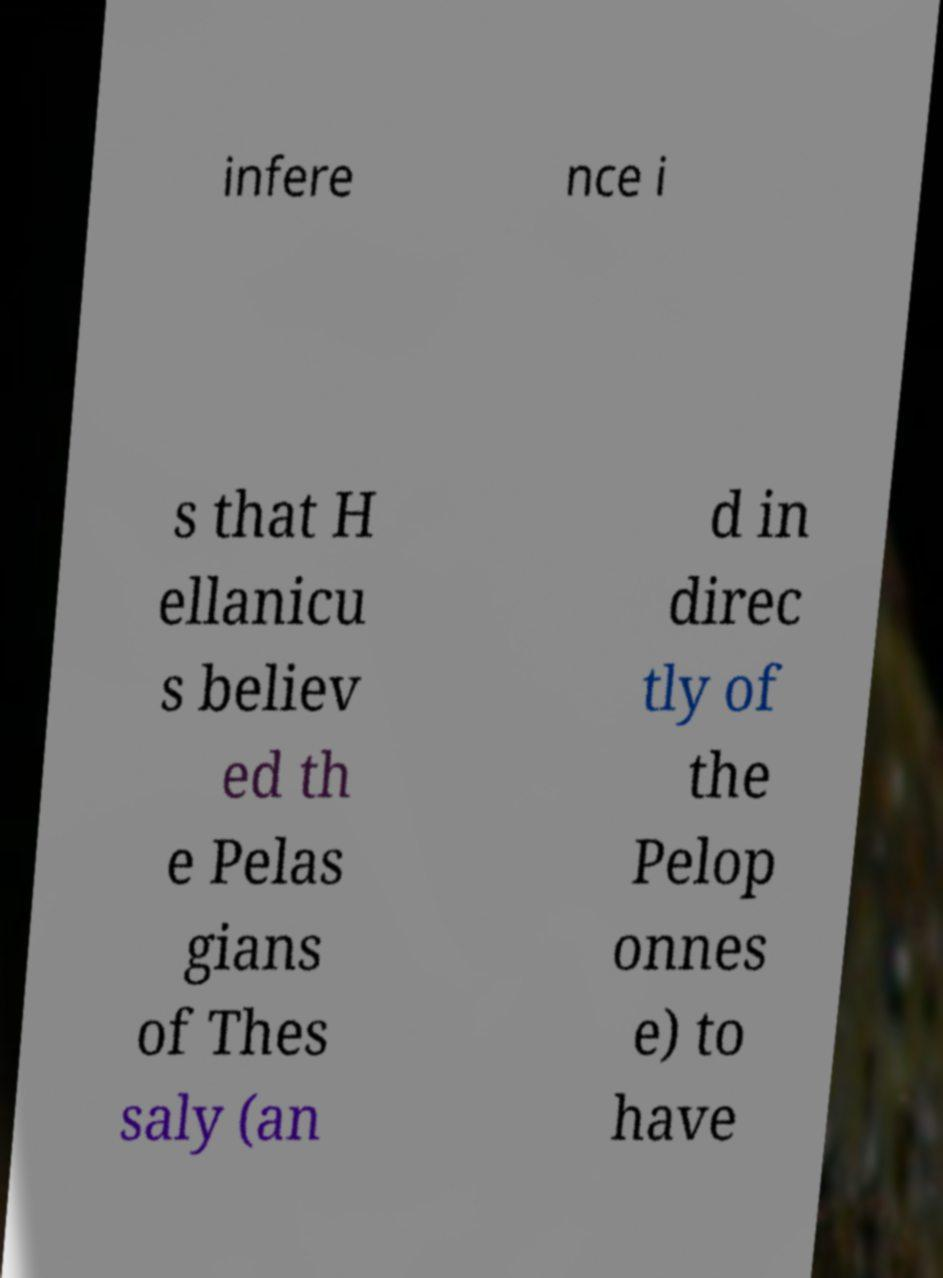Could you extract and type out the text from this image? infere nce i s that H ellanicu s believ ed th e Pelas gians of Thes saly (an d in direc tly of the Pelop onnes e) to have 